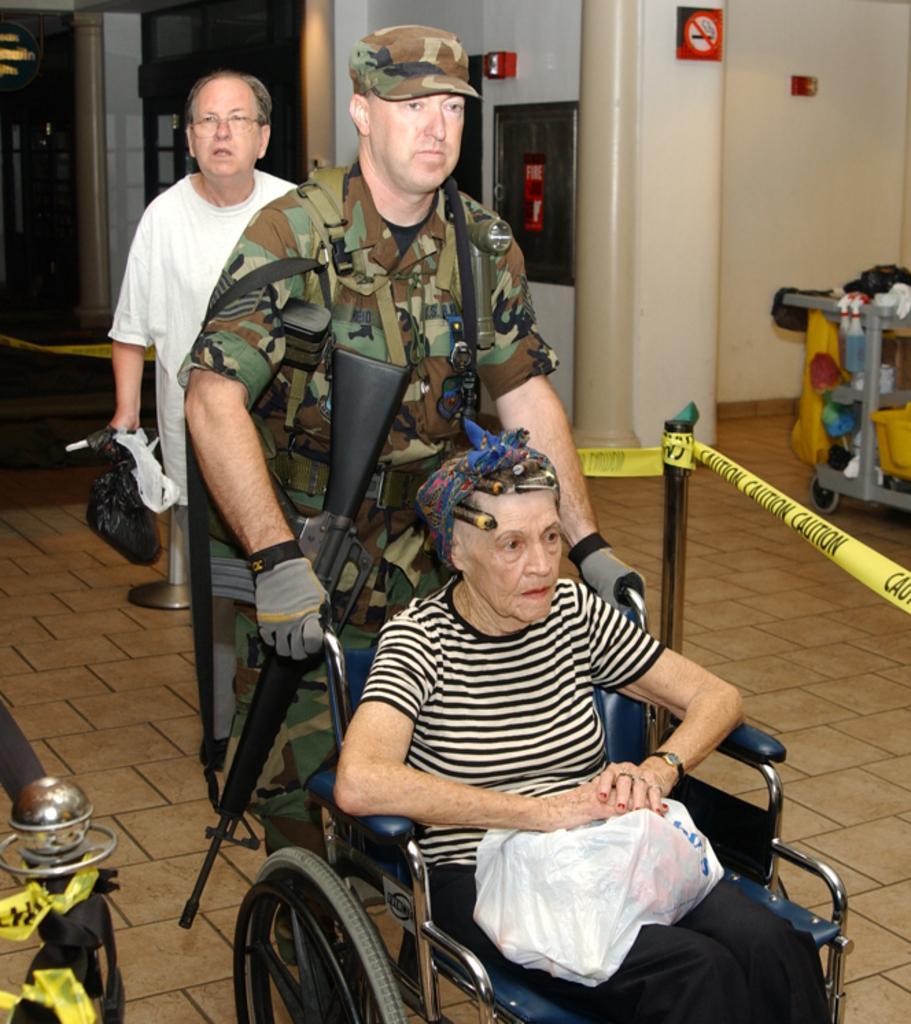Can you describe this image briefly? In this image there is an army personnel holding the wheelchair with a woman in it, behind the army personnel there is a man holding a bag in his hand, in the background of the image there are metal rods with fence, there are pillars, fire extinguishers and sign boards on the wall and there is an object. 